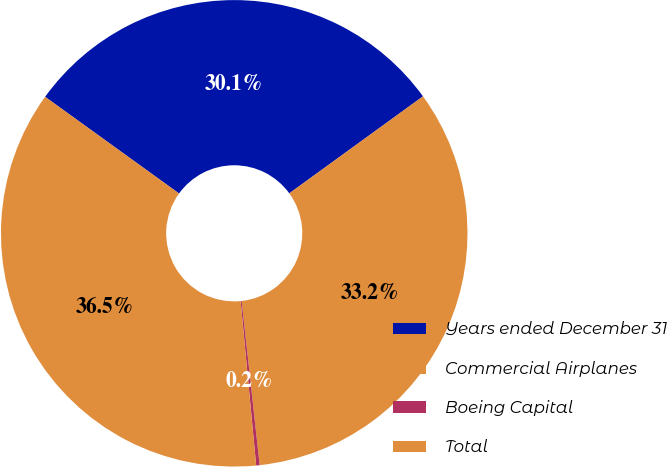<chart> <loc_0><loc_0><loc_500><loc_500><pie_chart><fcel>Years ended December 31<fcel>Commercial Airplanes<fcel>Boeing Capital<fcel>Total<nl><fcel>30.06%<fcel>33.25%<fcel>0.24%<fcel>36.45%<nl></chart> 